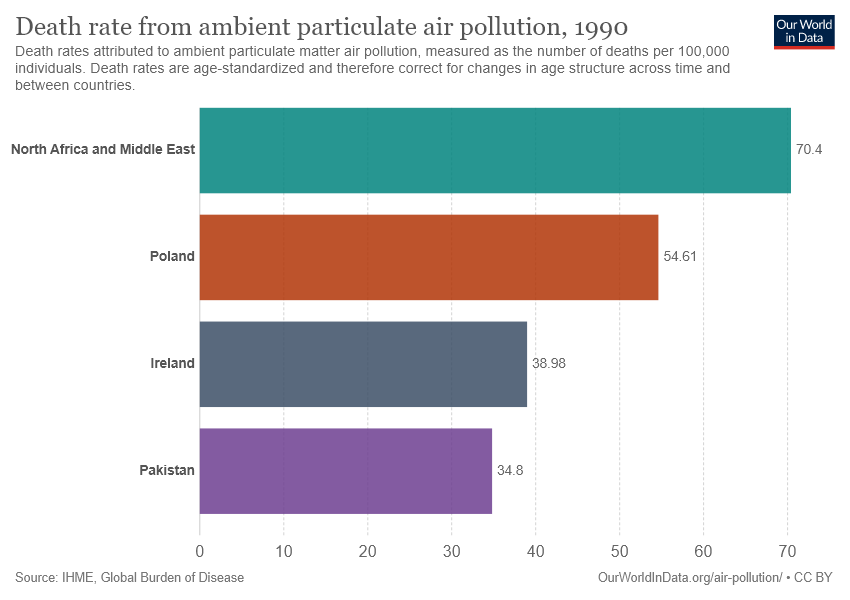Specify some key components in this picture. The sum of Poland and Ireland is 93.59. The highest death rate due to air pollution is 70.4%. 